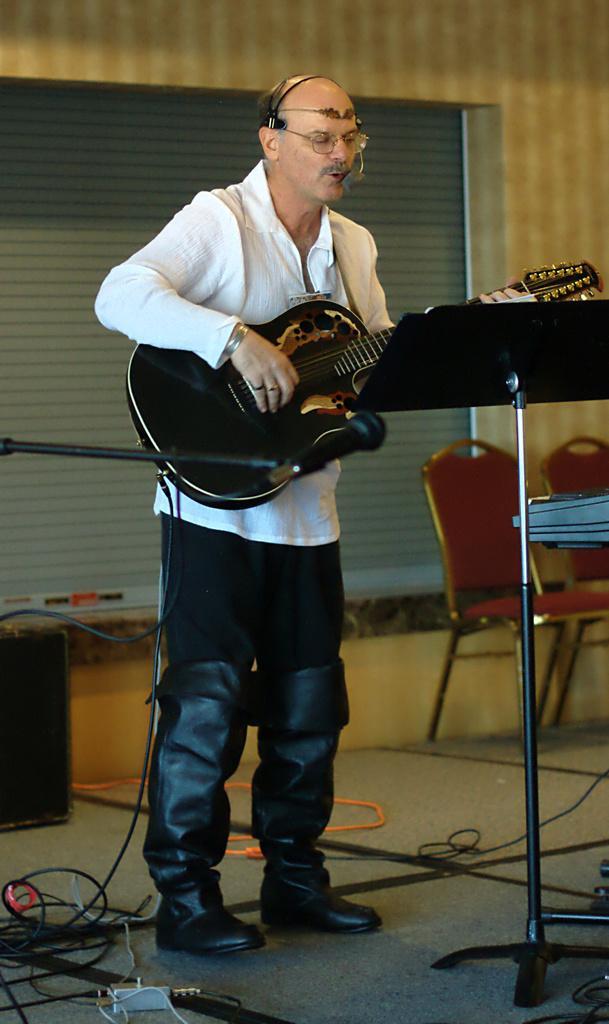Could you give a brief overview of what you see in this image? In the image we can see there is a man who is standing and holding guitar in his hand. 